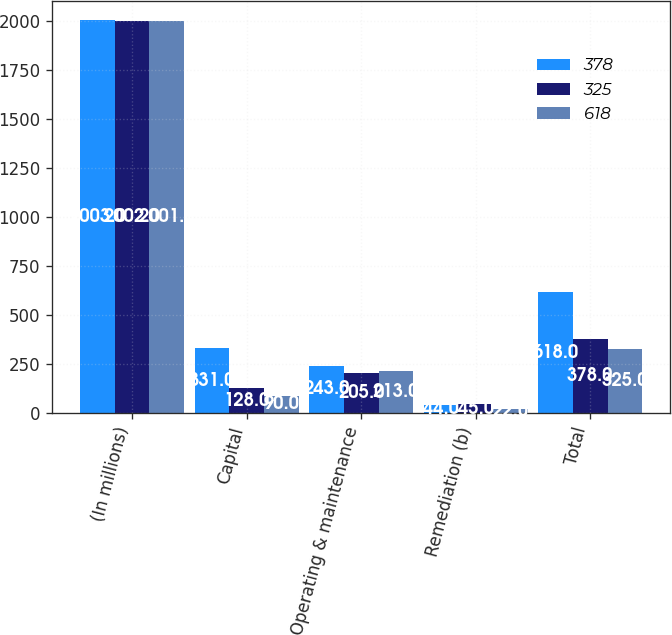Convert chart to OTSL. <chart><loc_0><loc_0><loc_500><loc_500><stacked_bar_chart><ecel><fcel>(In millions)<fcel>Capital<fcel>Operating & maintenance<fcel>Remediation (b)<fcel>Total<nl><fcel>378<fcel>2003<fcel>331<fcel>243<fcel>44<fcel>618<nl><fcel>325<fcel>2002<fcel>128<fcel>205<fcel>45<fcel>378<nl><fcel>618<fcel>2001<fcel>90<fcel>213<fcel>22<fcel>325<nl></chart> 